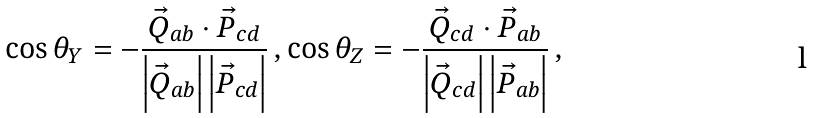<formula> <loc_0><loc_0><loc_500><loc_500>\cos \theta _ { Y } = - \frac { { \vec { Q } _ { a b } \cdot \vec { P } _ { c d } } } { { \left | { \vec { Q } _ { a b } } \right | \left | { \vec { P } _ { c d } } \right | } } \, , \cos \theta _ { Z } = - \frac { { \vec { Q } _ { c d } \cdot \vec { P } _ { a b } } } { { \left | { \vec { Q } _ { c d } } \right | \left | { \vec { P } _ { a b } } \right | } } \, ,</formula> 